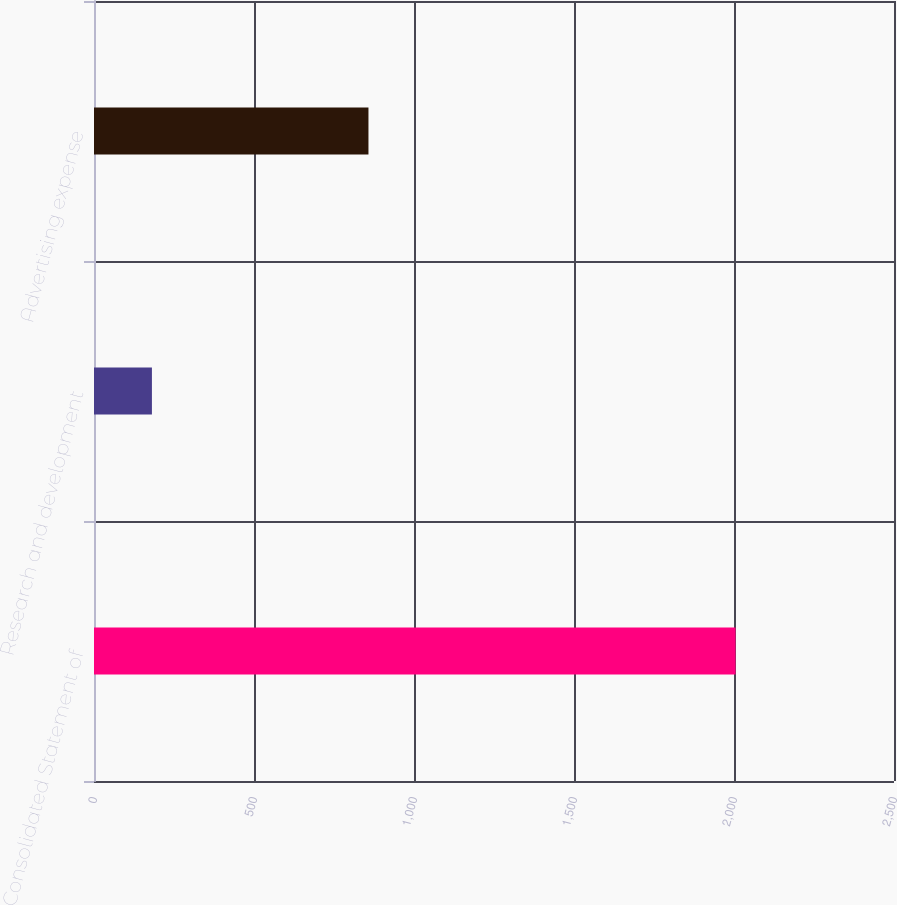Convert chart to OTSL. <chart><loc_0><loc_0><loc_500><loc_500><bar_chart><fcel>Consolidated Statement of<fcel>Research and development<fcel>Advertising expense<nl><fcel>2005<fcel>181<fcel>857.7<nl></chart> 